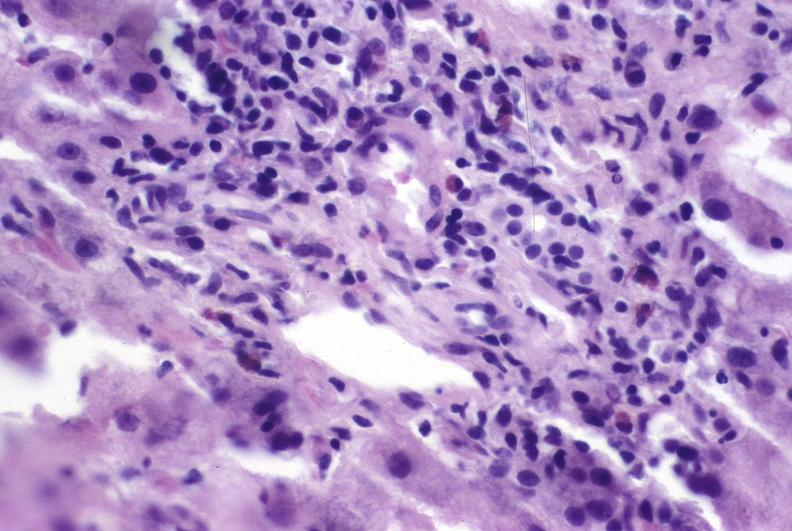s size present?
Answer the question using a single word or phrase. No 